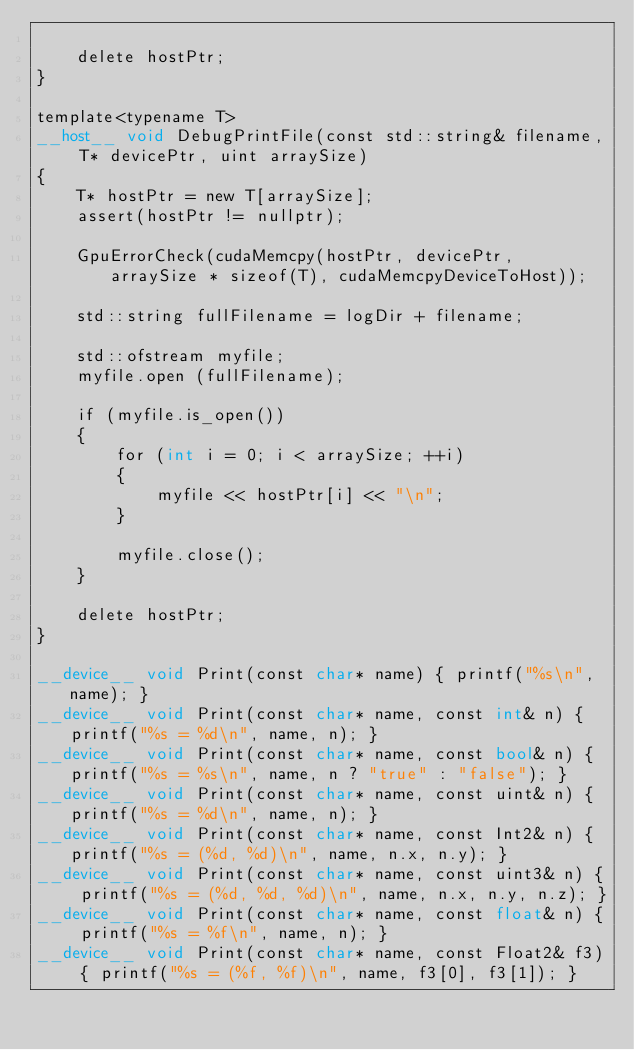Convert code to text. <code><loc_0><loc_0><loc_500><loc_500><_Cuda_>
	delete hostPtr;
}

template<typename T>
__host__ void DebugPrintFile(const std::string& filename, T* devicePtr, uint arraySize)
{
	T* hostPtr = new T[arraySize];
	assert(hostPtr != nullptr);

	GpuErrorCheck(cudaMemcpy(hostPtr, devicePtr, arraySize * sizeof(T), cudaMemcpyDeviceToHost));

	std::string fullFilename = logDir + filename;

	std::ofstream myfile;
	myfile.open (fullFilename);

	if (myfile.is_open())
	{
		for (int i = 0; i < arraySize; ++i)
		{
			myfile << hostPtr[i] << "\n";
		}

		myfile.close();
	}

	delete hostPtr;
}

__device__ void Print(const char* name) { printf("%s\n", name); }
__device__ void Print(const char* name, const int& n) { printf("%s = %d\n", name, n); }
__device__ void Print(const char* name, const bool& n) { printf("%s = %s\n", name, n ? "true" : "false"); }
__device__ void Print(const char* name, const uint& n) { printf("%s = %d\n", name, n); }
__device__ void Print(const char* name, const Int2& n) { printf("%s = (%d, %d)\n", name, n.x, n.y); }
__device__ void Print(const char* name, const uint3& n) { printf("%s = (%d, %d, %d)\n", name, n.x, n.y, n.z); }
__device__ void Print(const char* name, const float& n) { printf("%s = %f\n", name, n); }
__device__ void Print(const char* name, const Float2& f3) { printf("%s = (%f, %f)\n", name, f3[0], f3[1]); }</code> 